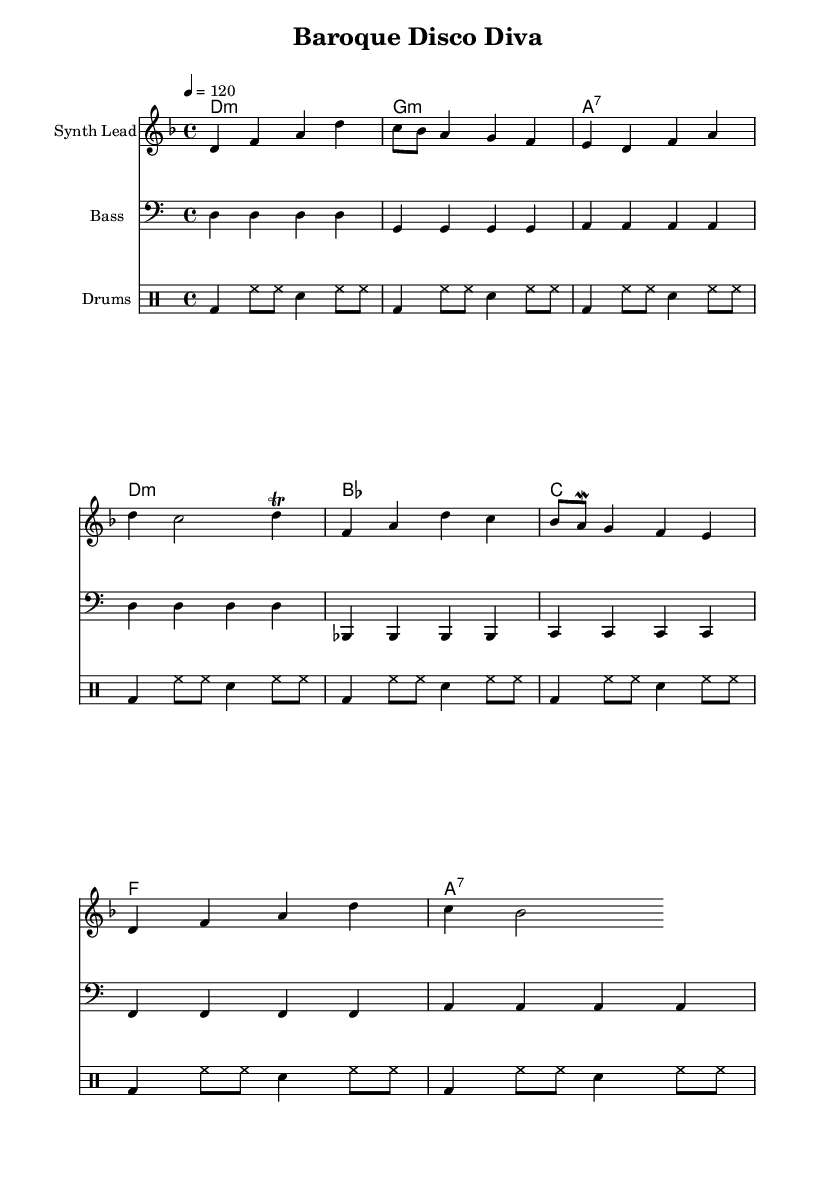What is the key signature of this music? The key signature is indicated by the number of sharps or flats at the beginning of the staff. The music is in D minor, which has one flat (B flat).
Answer: D minor What is the time signature of this music? The time signature is found at the beginning of the staff, represented as a fraction. This score shows a time signature of 4/4, meaning there are four beats in each measure, and the quarter note gets one beat.
Answer: 4/4 What is the tempo marking given in the score? The tempo marking is located above the staff, shown as a number followed by an equals sign, which indicates beats per minute. The score states "4 = 120", indicating a tempo of 120 beats per minute.
Answer: 120 How many measures are in the melody section? To determine the number of measures, count the groups of notes separated by vertical lines (bars) in the melody section. There are eight measures present in the melody.
Answer: 8 How many different instruments are represented in the score? The score lists distinct instrumental parts under the heading of "Score". There are three instrument parts: Synth Lead, Bass, and Drums. Hence, there are three different instruments represented.
Answer: 3 What type of arpeggio is present in the harmony section? The harmony section includes references to chords, indicated with a chord mode structure. The chords are primarily triadic forms, with some seventh chords indicated by the notation of “7”. The arpeggios are essentially built on triads and seventh chords.
Answer: Triadic Which notes are repeated in the bass line? To find the repeated notes, observe the bass section. The notes d and g appear as quarter notes consistently within their respective measures. Both notes repeat throughout the score.
Answer: D and G 